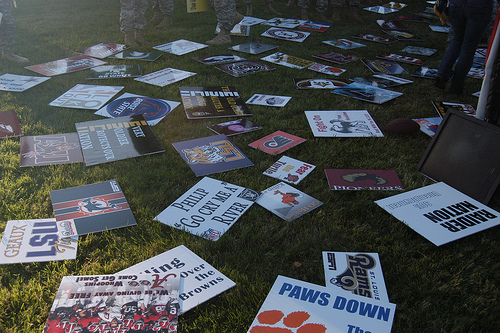<image>
Is there a paper on the grass? Yes. Looking at the image, I can see the paper is positioned on top of the grass, with the grass providing support. 